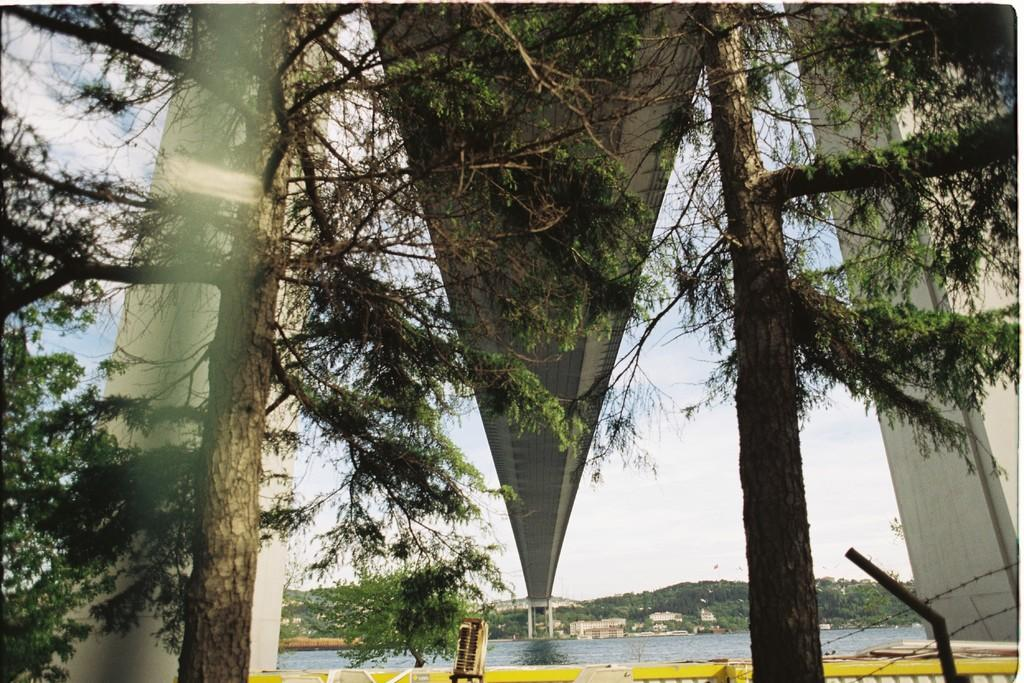What type of structure can be seen in the image? There is a bridge in the image. What type of vegetation is present in the image? There are trees in the image. What can be seen in the sky in the image? The sky is visible in the image, and clouds are present. What type of landscape feature is visible in the image? There are hills in the image. What natural element is visible in the image? Water is visible in the image. Can you see a hand holding a cactus in the image? No, there is no hand or cactus present in the image. Is the water in the image an ocean? No, the water in the image is not an ocean; it is not specified what type of water it is. 